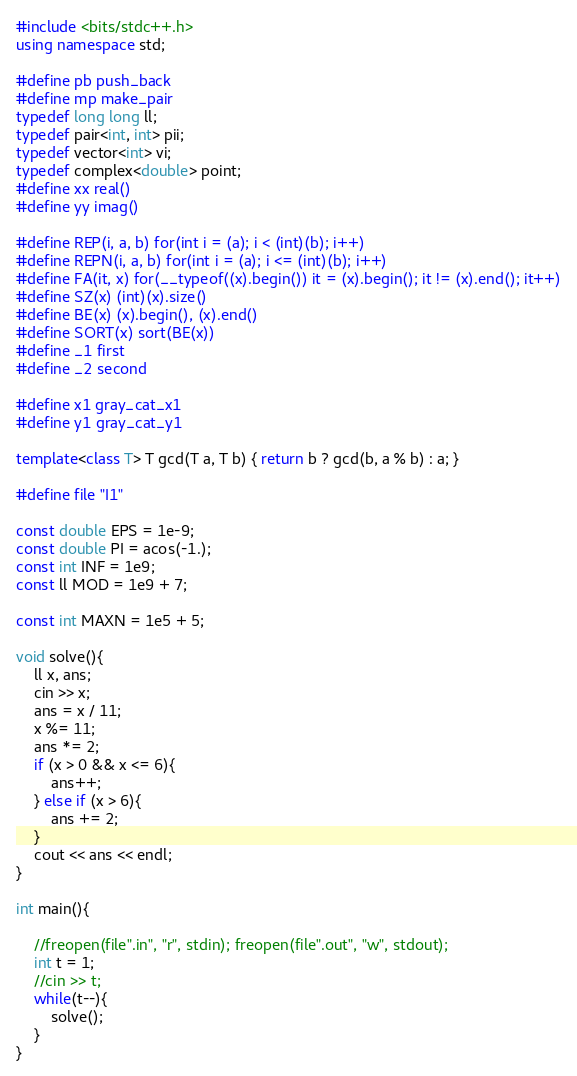Convert code to text. <code><loc_0><loc_0><loc_500><loc_500><_C++_>#include <bits/stdc++.h>
using namespace std;

#define pb push_back
#define mp make_pair
typedef long long ll;
typedef pair<int, int> pii;
typedef vector<int> vi;
typedef complex<double> point;
#define xx real()
#define yy imag()

#define REP(i, a, b) for(int i = (a); i < (int)(b); i++)
#define REPN(i, a, b) for(int i = (a); i <= (int)(b); i++)
#define FA(it, x) for(__typeof((x).begin()) it = (x).begin(); it != (x).end(); it++)
#define SZ(x) (int)(x).size()
#define BE(x) (x).begin(), (x).end()
#define SORT(x) sort(BE(x))
#define _1 first
#define _2 second

#define x1 gray_cat_x1
#define y1 gray_cat_y1

template<class T> T gcd(T a, T b) { return b ? gcd(b, a % b) : a; }

#define file "I1"

const double EPS = 1e-9;
const double PI = acos(-1.);
const int INF = 1e9;
const ll MOD = 1e9 + 7;

const int MAXN = 1e5 + 5;

void solve(){
	ll x, ans;
	cin >> x;
	ans = x / 11;
	x %= 11;
	ans *= 2;
	if (x > 0 && x <= 6){
		ans++;
	} else if (x > 6){
		ans += 2;
	}
	cout << ans << endl;
}   

int main(){

    //freopen(file".in", "r", stdin); freopen(file".out", "w", stdout);
    int t = 1;
    //cin >> t;
    while(t--){
        solve();    
    }
}
</code> 